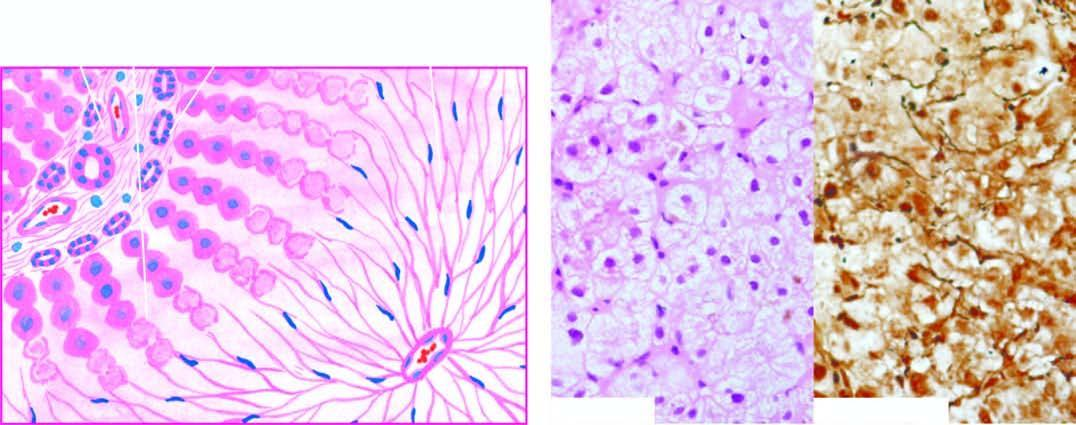reticulin framework left out in whose place , high lighted by reticulin stain?
Answer the question using a single word or phrase. Their 